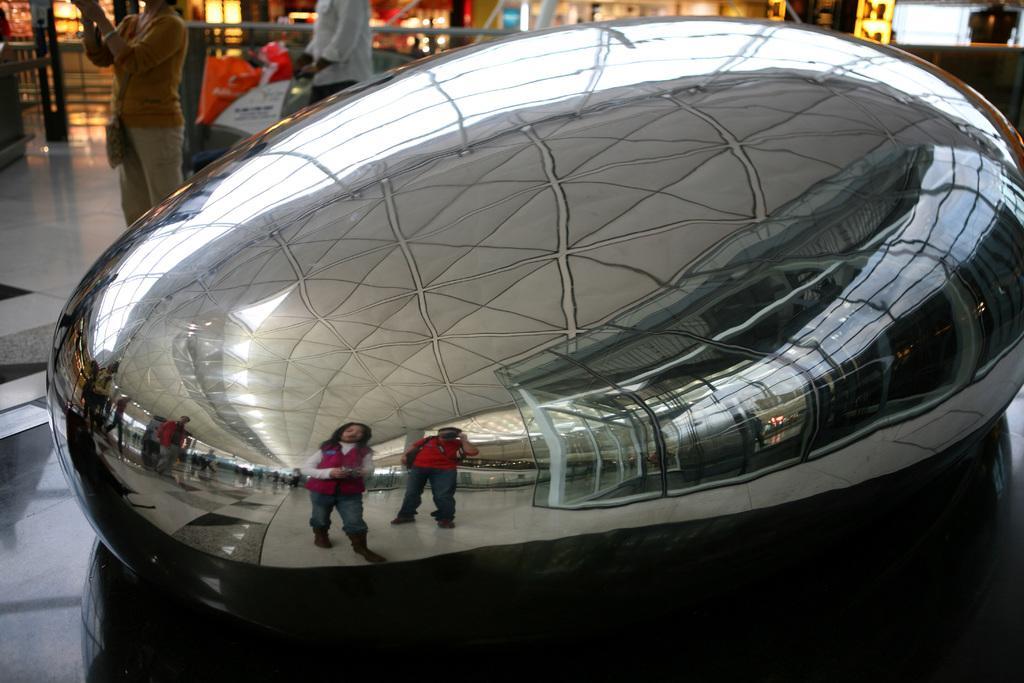Can you describe this image briefly? In the picture we can see an oval shaped mirror structure which is kept on the floor and in that we can see the images of some persons standing, roof of the building and some glass cabins and behind the oval shaped structure we can see some people are standing and in the background we can see some shops and lights. 